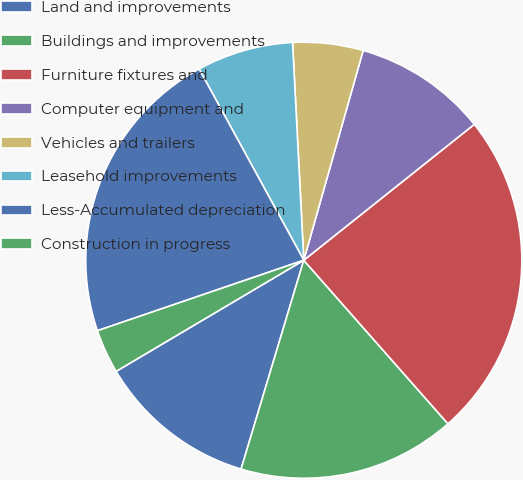<chart> <loc_0><loc_0><loc_500><loc_500><pie_chart><fcel>Land and improvements<fcel>Buildings and improvements<fcel>Furniture fixtures and<fcel>Computer equipment and<fcel>Vehicles and trailers<fcel>Leasehold improvements<fcel>Less-Accumulated depreciation<fcel>Construction in progress<nl><fcel>11.85%<fcel>16.14%<fcel>24.21%<fcel>9.9%<fcel>5.21%<fcel>7.15%<fcel>22.27%<fcel>3.27%<nl></chart> 